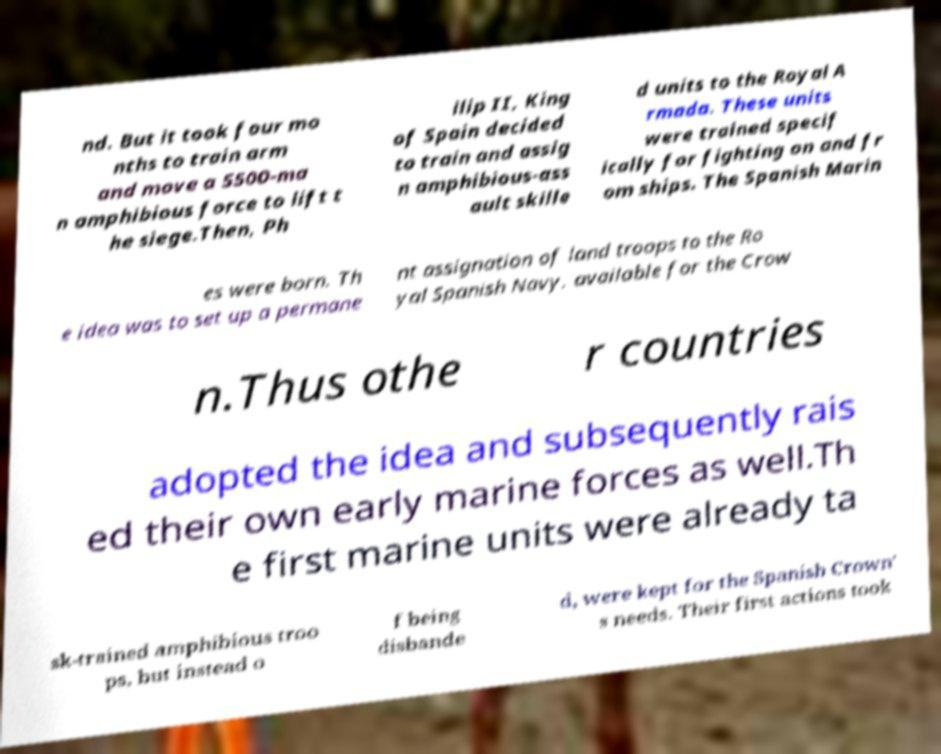Please identify and transcribe the text found in this image. nd. But it took four mo nths to train arm and move a 5500-ma n amphibious force to lift t he siege.Then, Ph ilip II, King of Spain decided to train and assig n amphibious-ass ault skille d units to the Royal A rmada. These units were trained specif ically for fighting on and fr om ships. The Spanish Marin es were born. Th e idea was to set up a permane nt assignation of land troops to the Ro yal Spanish Navy, available for the Crow n.Thus othe r countries adopted the idea and subsequently rais ed their own early marine forces as well.Th e first marine units were already ta sk-trained amphibious troo ps, but instead o f being disbande d, were kept for the Spanish Crown' s needs. Their first actions took 